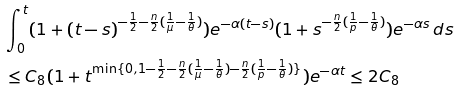Convert formula to latex. <formula><loc_0><loc_0><loc_500><loc_500>& \int _ { 0 } ^ { t } ( 1 + ( t - s ) ^ { - \frac { 1 } { 2 } - \frac { n } { 2 } ( \frac { 1 } { \mu } - \frac { 1 } { \theta } ) } ) e ^ { - \alpha ( t - s ) } ( 1 + s ^ { - \frac { n } { 2 } ( \frac { 1 } { p } - \frac { 1 } { \theta } ) } ) e ^ { - \alpha s } \, d s \\ & \leq C _ { 8 } ( 1 + t ^ { \min \{ 0 , 1 - \frac { 1 } { 2 } - \frac { n } { 2 } ( \frac { 1 } { \mu } - \frac { 1 } { \theta } ) - \frac { n } { 2 } ( \frac { 1 } { p } - \frac { 1 } { \theta } ) \} } ) e ^ { - \alpha t } \leq 2 C _ { 8 }</formula> 